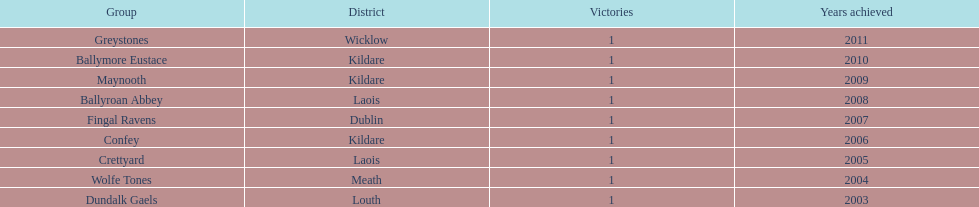What is the difference years won for crettyard and greystones 6. 